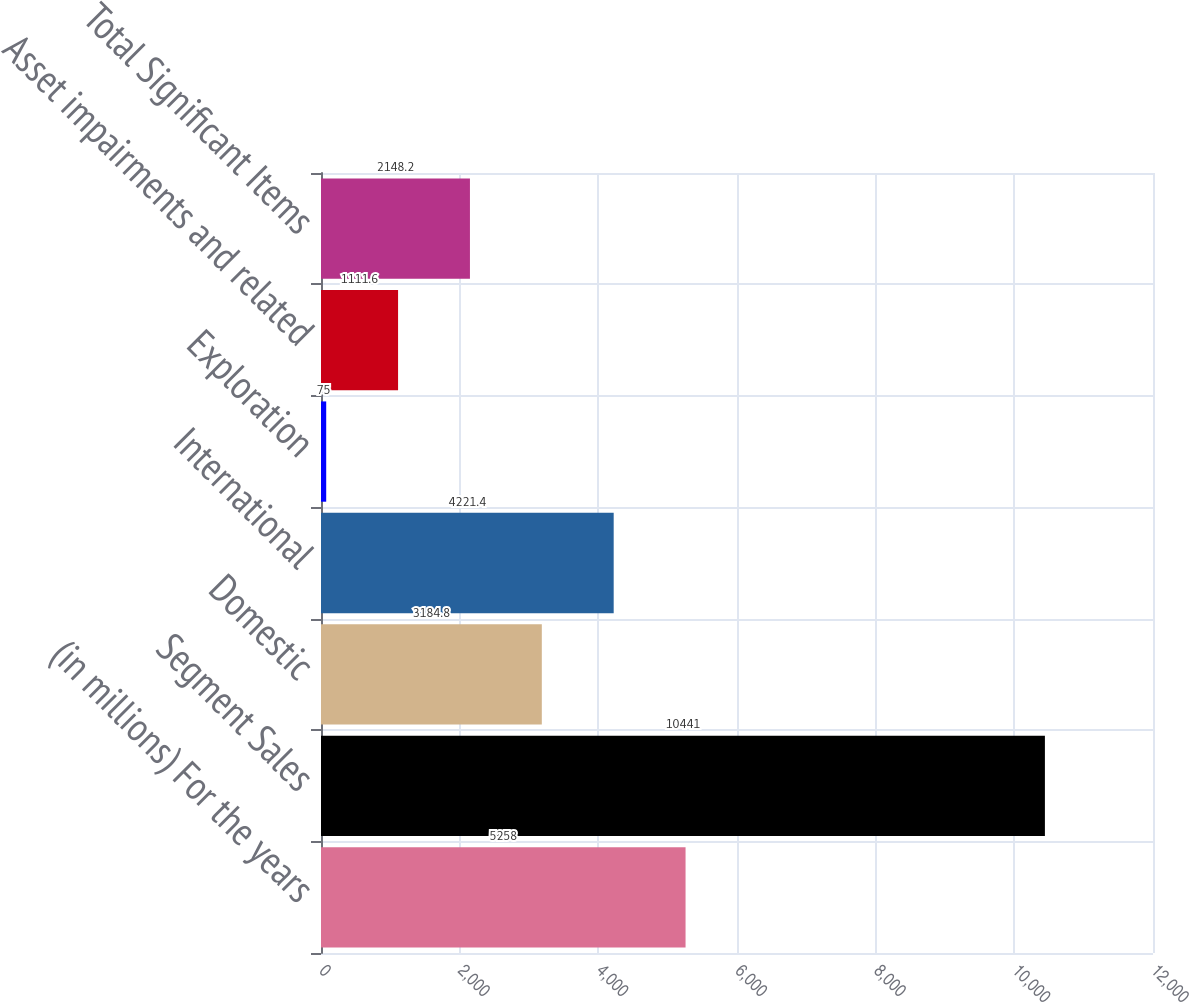<chart> <loc_0><loc_0><loc_500><loc_500><bar_chart><fcel>(in millions) For the years<fcel>Segment Sales<fcel>Domestic<fcel>International<fcel>Exploration<fcel>Asset impairments and related<fcel>Total Significant Items<nl><fcel>5258<fcel>10441<fcel>3184.8<fcel>4221.4<fcel>75<fcel>1111.6<fcel>2148.2<nl></chart> 